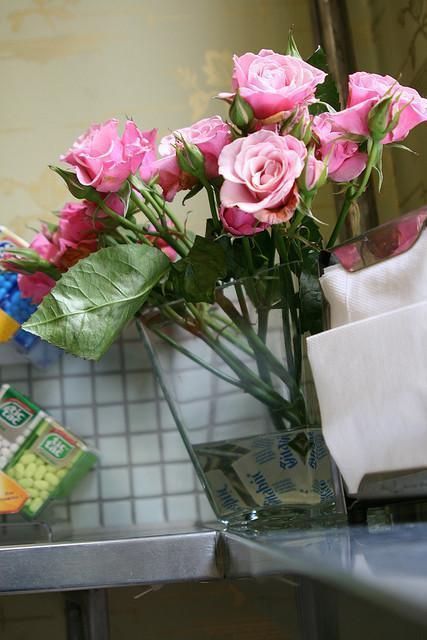How many flavors of tic tacs are there?
Give a very brief answer. 2. 